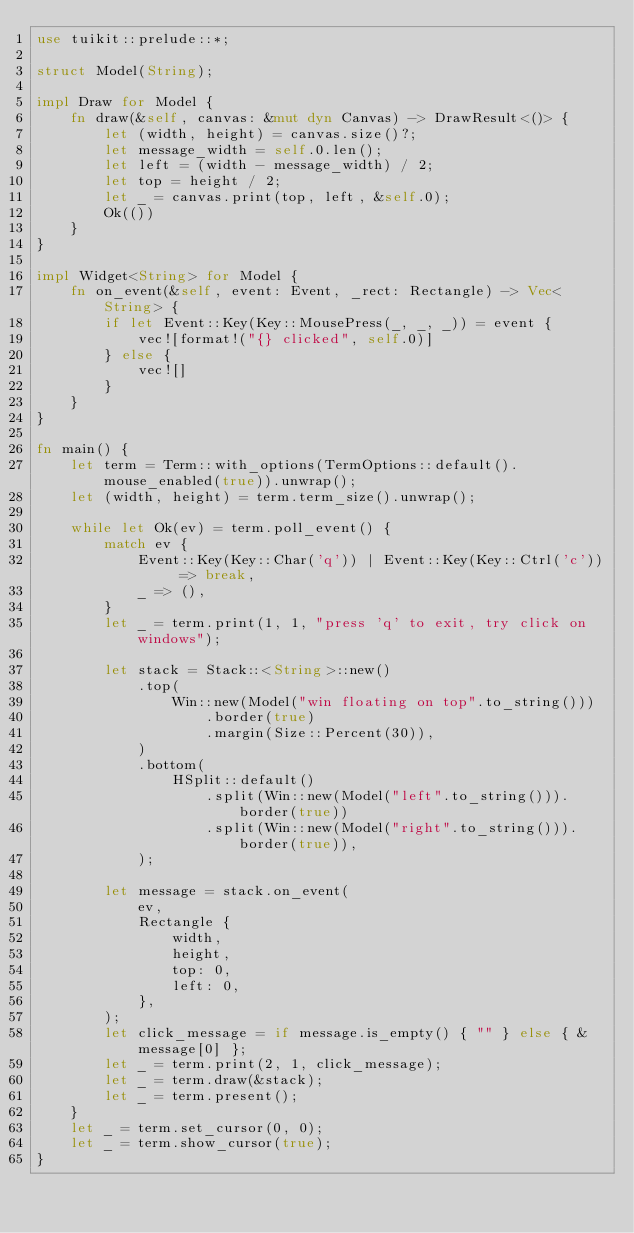<code> <loc_0><loc_0><loc_500><loc_500><_Rust_>use tuikit::prelude::*;

struct Model(String);

impl Draw for Model {
    fn draw(&self, canvas: &mut dyn Canvas) -> DrawResult<()> {
        let (width, height) = canvas.size()?;
        let message_width = self.0.len();
        let left = (width - message_width) / 2;
        let top = height / 2;
        let _ = canvas.print(top, left, &self.0);
        Ok(())
    }
}

impl Widget<String> for Model {
    fn on_event(&self, event: Event, _rect: Rectangle) -> Vec<String> {
        if let Event::Key(Key::MousePress(_, _, _)) = event {
            vec![format!("{} clicked", self.0)]
        } else {
            vec![]
        }
    }
}

fn main() {
    let term = Term::with_options(TermOptions::default().mouse_enabled(true)).unwrap();
    let (width, height) = term.term_size().unwrap();

    while let Ok(ev) = term.poll_event() {
        match ev {
            Event::Key(Key::Char('q')) | Event::Key(Key::Ctrl('c')) => break,
            _ => (),
        }
        let _ = term.print(1, 1, "press 'q' to exit, try click on windows");

        let stack = Stack::<String>::new()
            .top(
                Win::new(Model("win floating on top".to_string()))
                    .border(true)
                    .margin(Size::Percent(30)),
            )
            .bottom(
                HSplit::default()
                    .split(Win::new(Model("left".to_string())).border(true))
                    .split(Win::new(Model("right".to_string())).border(true)),
            );

        let message = stack.on_event(
            ev,
            Rectangle {
                width,
                height,
                top: 0,
                left: 0,
            },
        );
        let click_message = if message.is_empty() { "" } else { &message[0] };
        let _ = term.print(2, 1, click_message);
        let _ = term.draw(&stack);
        let _ = term.present();
    }
    let _ = term.set_cursor(0, 0);
    let _ = term.show_cursor(true);
}
</code> 